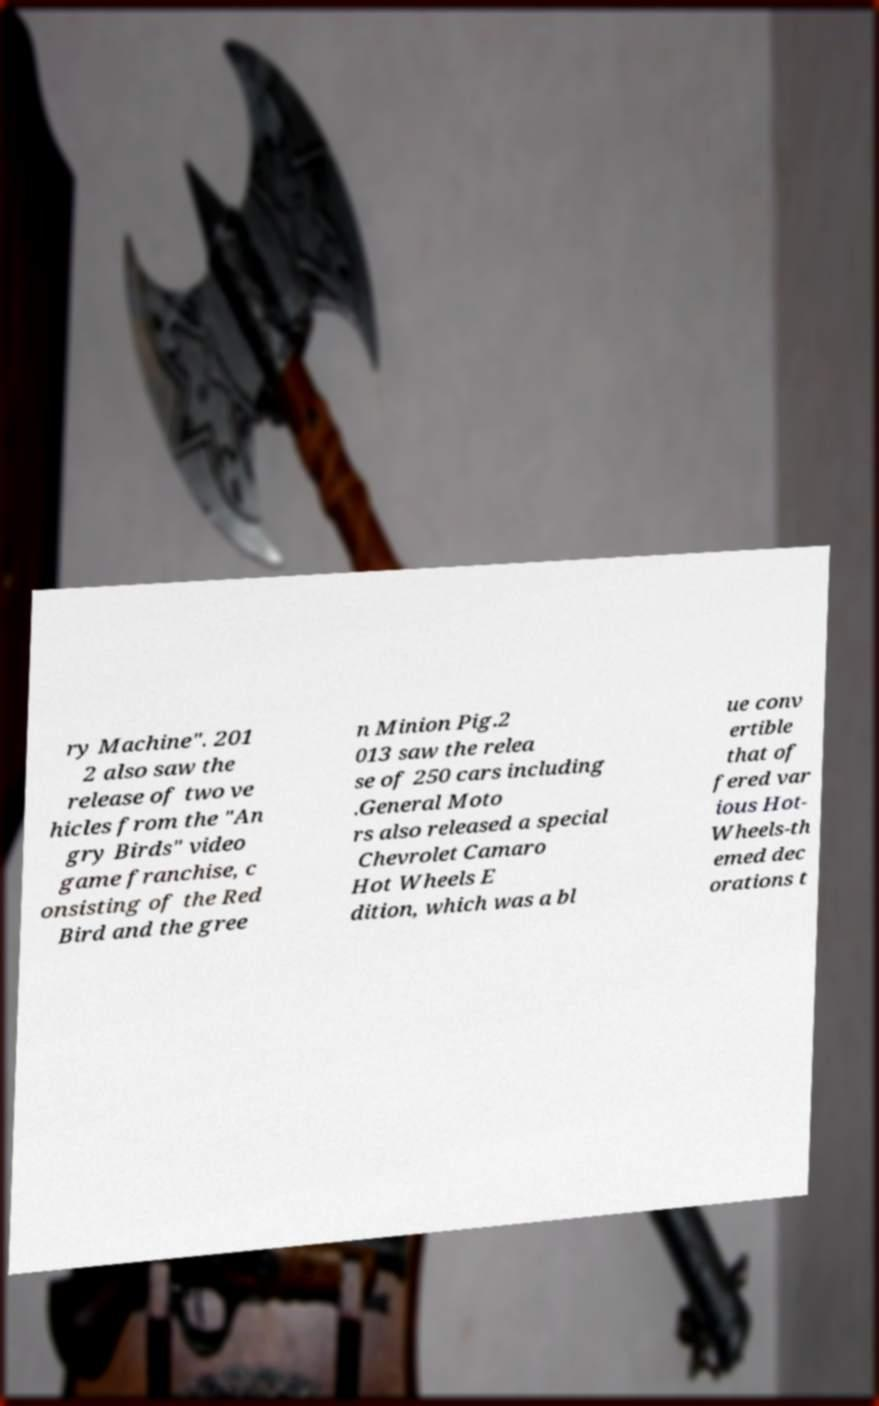There's text embedded in this image that I need extracted. Can you transcribe it verbatim? ry Machine". 201 2 also saw the release of two ve hicles from the "An gry Birds" video game franchise, c onsisting of the Red Bird and the gree n Minion Pig.2 013 saw the relea se of 250 cars including .General Moto rs also released a special Chevrolet Camaro Hot Wheels E dition, which was a bl ue conv ertible that of fered var ious Hot- Wheels-th emed dec orations t 